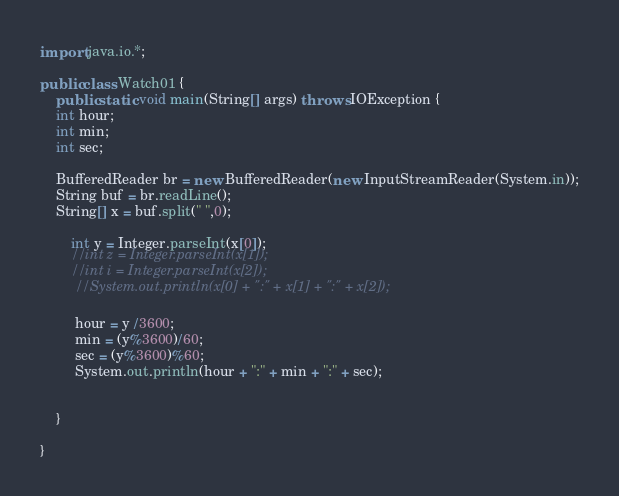<code> <loc_0><loc_0><loc_500><loc_500><_Java_>import java.io.*;  

public class Watch01 {
    public static void main(String[] args) throws IOException {
	int hour;                                         
	int min;                                          
	int sec;                                          
    	
	BufferedReader br = new BufferedReader(new InputStreamReader(System.in));
	String buf = br.readLine();
    String[] x = buf.split(" ",0);
    	
    	int y = Integer.parseInt(x[0]);
    	//int z = Integer.parseInt(x[1]);
        //int i = Integer.parseInt(x[2]);
    	 //System.out.println(x[0] + ":" + x[1] + ":" + x[2]);
    	 
    	 hour = y /3600;
    	 min = (y%3600)/60;
    	 sec = (y%3600)%60;
    	 System.out.println(hour + ":" + min + ":" + sec); 
    	
	    
    }
    
}</code> 